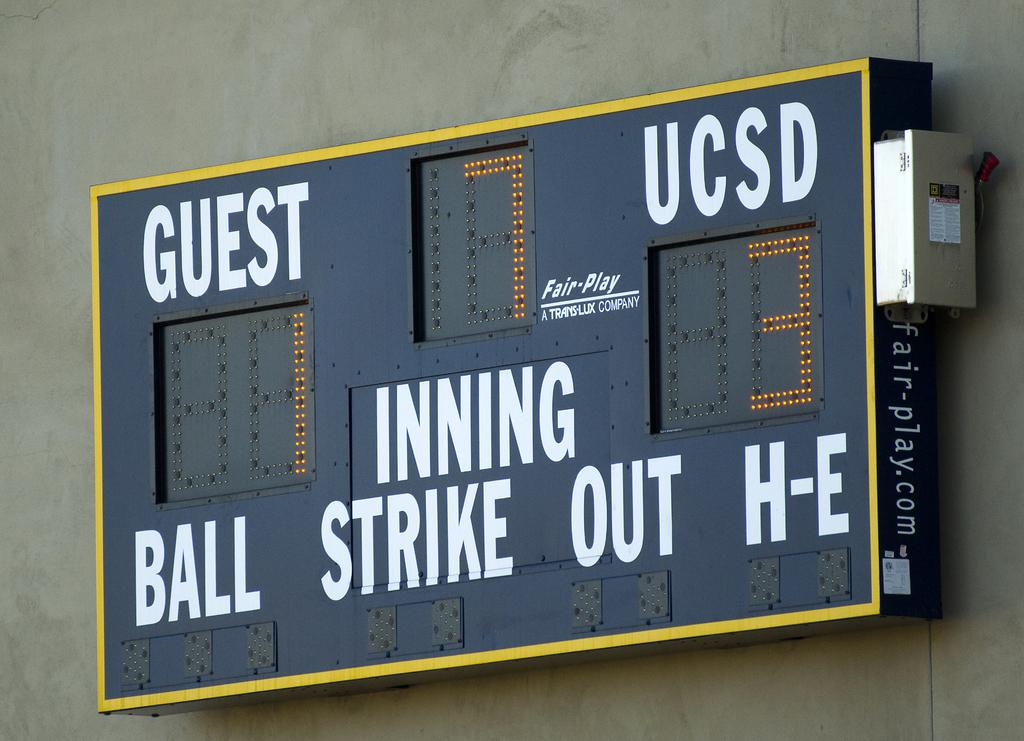What is located on the wall in the picture? There is a scoreboard on the wall in the picture. Where is the scoreboard positioned in the picture? The scoreboard is in the middle of the picture. What can be seen on the scoreboard? There is text on the scoreboard. How are the numbers displayed on the scoreboard? The scoreboard has LED lights. What type of pest can be seen crawling on the scoreboard in the image? There are no pests visible on the scoreboard in the image. What is located at the front of the scoreboard in the image? The provided facts do not mention anything being located at the front of the scoreboard. 